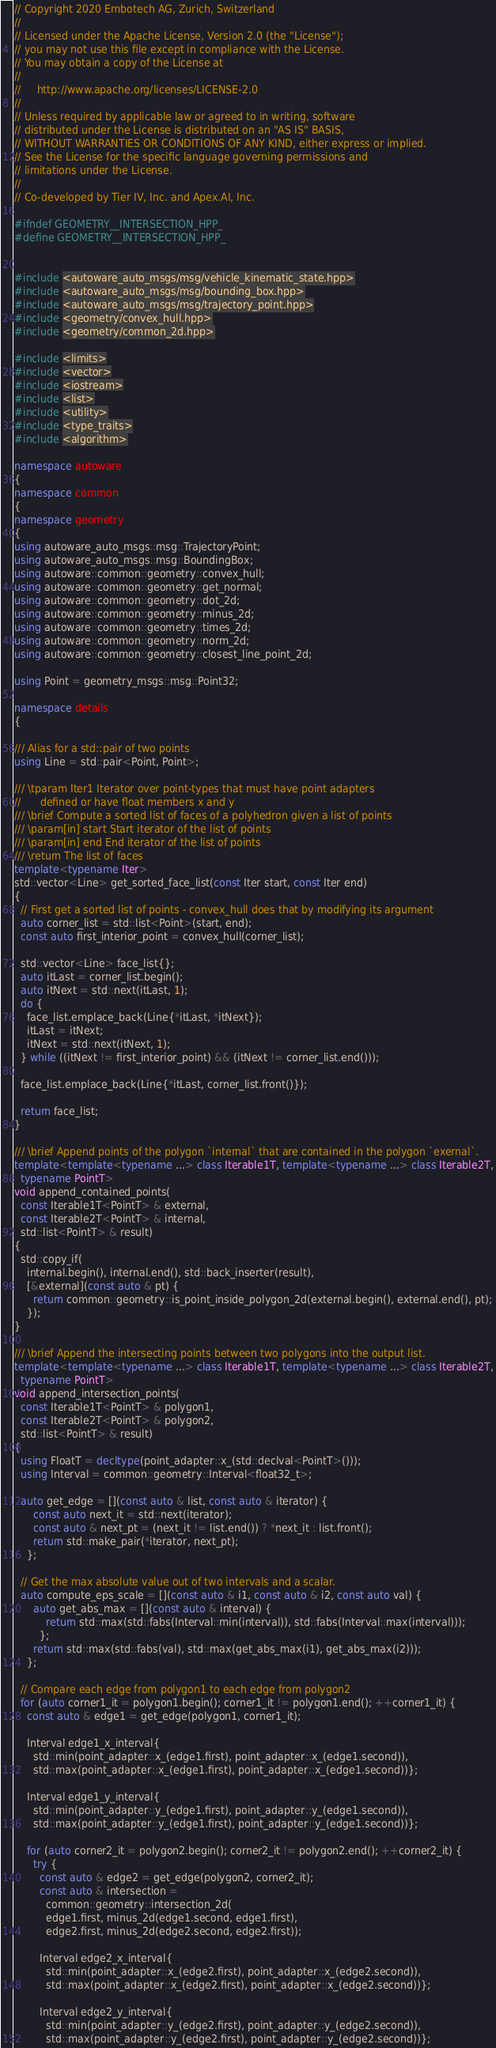<code> <loc_0><loc_0><loc_500><loc_500><_C++_>// Copyright 2020 Embotech AG, Zurich, Switzerland
//
// Licensed under the Apache License, Version 2.0 (the "License");
// you may not use this file except in compliance with the License.
// You may obtain a copy of the License at
//
//     http://www.apache.org/licenses/LICENSE-2.0
//
// Unless required by applicable law or agreed to in writing, software
// distributed under the License is distributed on an "AS IS" BASIS,
// WITHOUT WARRANTIES OR CONDITIONS OF ANY KIND, either express or implied.
// See the License for the specific language governing permissions and
// limitations under the License.
//
// Co-developed by Tier IV, Inc. and Apex.AI, Inc.

#ifndef GEOMETRY__INTERSECTION_HPP_
#define GEOMETRY__INTERSECTION_HPP_


#include <autoware_auto_msgs/msg/vehicle_kinematic_state.hpp>
#include <autoware_auto_msgs/msg/bounding_box.hpp>
#include <autoware_auto_msgs/msg/trajectory_point.hpp>
#include <geometry/convex_hull.hpp>
#include <geometry/common_2d.hpp>

#include <limits>
#include <vector>
#include <iostream>
#include <list>
#include <utility>
#include <type_traits>
#include <algorithm>

namespace autoware
{
namespace common
{
namespace geometry
{
using autoware_auto_msgs::msg::TrajectoryPoint;
using autoware_auto_msgs::msg::BoundingBox;
using autoware::common::geometry::convex_hull;
using autoware::common::geometry::get_normal;
using autoware::common::geometry::dot_2d;
using autoware::common::geometry::minus_2d;
using autoware::common::geometry::times_2d;
using autoware::common::geometry::norm_2d;
using autoware::common::geometry::closest_line_point_2d;

using Point = geometry_msgs::msg::Point32;

namespace details
{

/// Alias for a std::pair of two points
using Line = std::pair<Point, Point>;

/// \tparam Iter1 Iterator over point-types that must have point adapters
//      defined or have float members x and y
/// \brief Compute a sorted list of faces of a polyhedron given a list of points
/// \param[in] start Start iterator of the list of points
/// \param[in] end End iterator of the list of points
/// \return The list of faces
template<typename Iter>
std::vector<Line> get_sorted_face_list(const Iter start, const Iter end)
{
  // First get a sorted list of points - convex_hull does that by modifying its argument
  auto corner_list = std::list<Point>(start, end);
  const auto first_interior_point = convex_hull(corner_list);

  std::vector<Line> face_list{};
  auto itLast = corner_list.begin();
  auto itNext = std::next(itLast, 1);
  do {
    face_list.emplace_back(Line{*itLast, *itNext});
    itLast = itNext;
    itNext = std::next(itNext, 1);
  } while ((itNext != first_interior_point) && (itNext != corner_list.end()));

  face_list.emplace_back(Line{*itLast, corner_list.front()});

  return face_list;
}

/// \brief Append points of the polygon `internal` that are contained in the polygon `exernal`.
template<template<typename ...> class Iterable1T, template<typename ...> class Iterable2T,
  typename PointT>
void append_contained_points(
  const Iterable1T<PointT> & external,
  const Iterable2T<PointT> & internal,
  std::list<PointT> & result)
{
  std::copy_if(
    internal.begin(), internal.end(), std::back_inserter(result),
    [&external](const auto & pt) {
      return common::geometry::is_point_inside_polygon_2d(external.begin(), external.end(), pt);
    });
}

/// \brief Append the intersecting points between two polygons into the output list.
template<template<typename ...> class Iterable1T, template<typename ...> class Iterable2T,
  typename PointT>
void append_intersection_points(
  const Iterable1T<PointT> & polygon1,
  const Iterable2T<PointT> & polygon2,
  std::list<PointT> & result)
{
  using FloatT = decltype(point_adapter::x_(std::declval<PointT>()));
  using Interval = common::geometry::Interval<float32_t>;

  auto get_edge = [](const auto & list, const auto & iterator) {
      const auto next_it = std::next(iterator);
      const auto & next_pt = (next_it != list.end()) ? *next_it : list.front();
      return std::make_pair(*iterator, next_pt);
    };

  // Get the max absolute value out of two intervals and a scalar.
  auto compute_eps_scale = [](const auto & i1, const auto & i2, const auto val) {
      auto get_abs_max = [](const auto & interval) {
          return std::max(std::fabs(Interval::min(interval)), std::fabs(Interval::max(interval)));
        };
      return std::max(std::fabs(val), std::max(get_abs_max(i1), get_abs_max(i2)));
    };

  // Compare each edge from polygon1 to each edge from polygon2
  for (auto corner1_it = polygon1.begin(); corner1_it != polygon1.end(); ++corner1_it) {
    const auto & edge1 = get_edge(polygon1, corner1_it);

    Interval edge1_x_interval{
      std::min(point_adapter::x_(edge1.first), point_adapter::x_(edge1.second)),
      std::max(point_adapter::x_(edge1.first), point_adapter::x_(edge1.second))};

    Interval edge1_y_interval{
      std::min(point_adapter::y_(edge1.first), point_adapter::y_(edge1.second)),
      std::max(point_adapter::y_(edge1.first), point_adapter::y_(edge1.second))};

    for (auto corner2_it = polygon2.begin(); corner2_it != polygon2.end(); ++corner2_it) {
      try {
        const auto & edge2 = get_edge(polygon2, corner2_it);
        const auto & intersection =
          common::geometry::intersection_2d(
          edge1.first, minus_2d(edge1.second, edge1.first),
          edge2.first, minus_2d(edge2.second, edge2.first));

        Interval edge2_x_interval{
          std::min(point_adapter::x_(edge2.first), point_adapter::x_(edge2.second)),
          std::max(point_adapter::x_(edge2.first), point_adapter::x_(edge2.second))};

        Interval edge2_y_interval{
          std::min(point_adapter::y_(edge2.first), point_adapter::y_(edge2.second)),
          std::max(point_adapter::y_(edge2.first), point_adapter::y_(edge2.second))};
</code> 